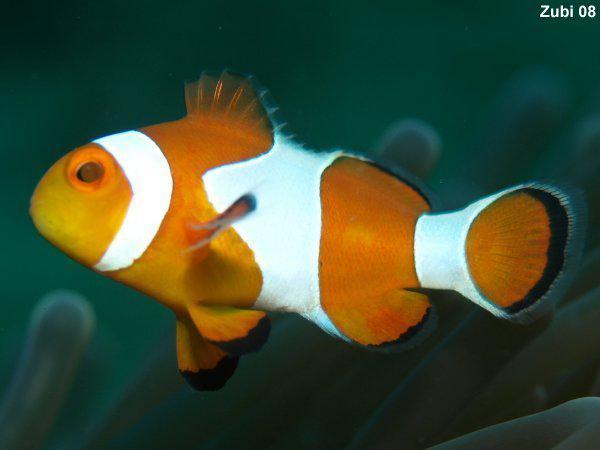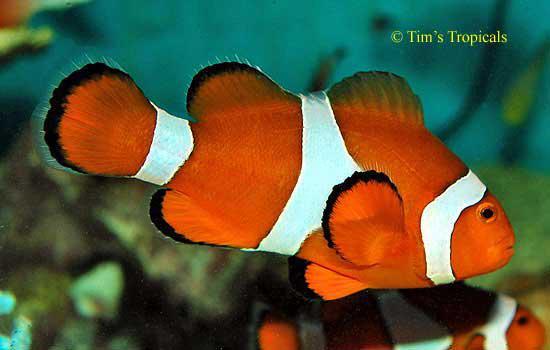The first image is the image on the left, the second image is the image on the right. Evaluate the accuracy of this statement regarding the images: "The clown fish in the left and right images face toward each other.". Is it true? Answer yes or no. No. 